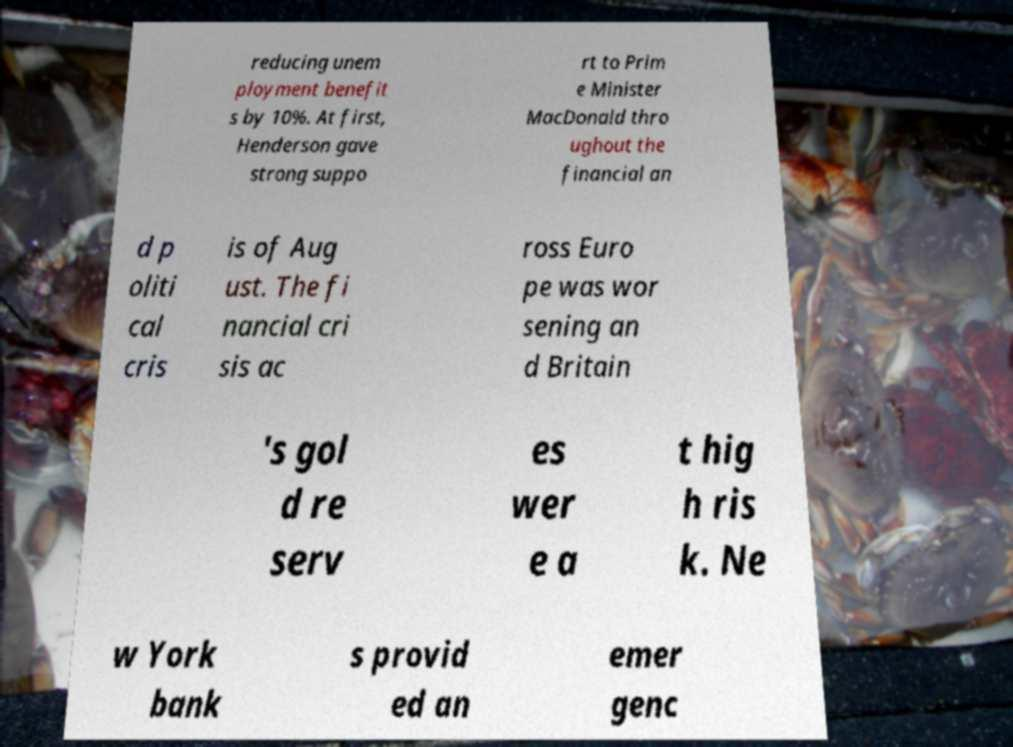For documentation purposes, I need the text within this image transcribed. Could you provide that? reducing unem ployment benefit s by 10%. At first, Henderson gave strong suppo rt to Prim e Minister MacDonald thro ughout the financial an d p oliti cal cris is of Aug ust. The fi nancial cri sis ac ross Euro pe was wor sening an d Britain 's gol d re serv es wer e a t hig h ris k. Ne w York bank s provid ed an emer genc 